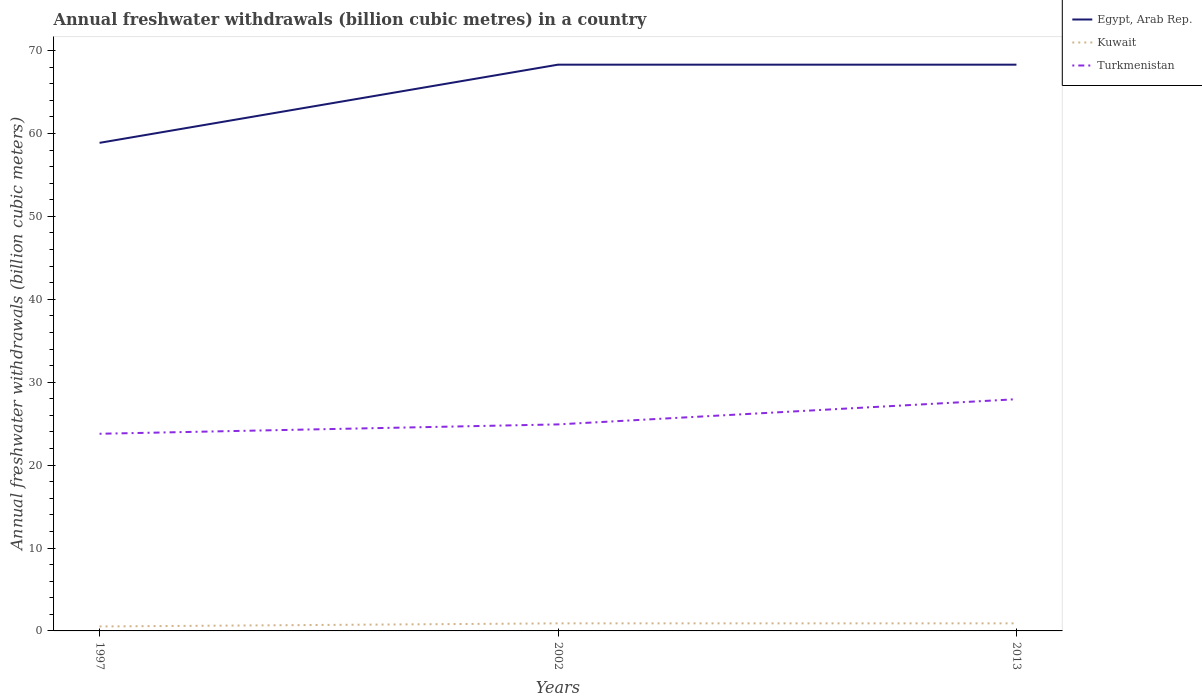Does the line corresponding to Egypt, Arab Rep. intersect with the line corresponding to Turkmenistan?
Your answer should be compact. No. Across all years, what is the maximum annual freshwater withdrawals in Kuwait?
Keep it short and to the point. 0.54. In which year was the annual freshwater withdrawals in Egypt, Arab Rep. maximum?
Provide a succinct answer. 1997. What is the total annual freshwater withdrawals in Turkmenistan in the graph?
Make the answer very short. -3.04. What is the difference between the highest and the second highest annual freshwater withdrawals in Egypt, Arab Rep.?
Your answer should be very brief. 9.43. What is the difference between the highest and the lowest annual freshwater withdrawals in Kuwait?
Offer a terse response. 2. Is the annual freshwater withdrawals in Turkmenistan strictly greater than the annual freshwater withdrawals in Kuwait over the years?
Provide a succinct answer. No. How many lines are there?
Your response must be concise. 3. How many years are there in the graph?
Your response must be concise. 3. What is the difference between two consecutive major ticks on the Y-axis?
Offer a very short reply. 10. Are the values on the major ticks of Y-axis written in scientific E-notation?
Make the answer very short. No. Where does the legend appear in the graph?
Your answer should be compact. Top right. How many legend labels are there?
Offer a very short reply. 3. What is the title of the graph?
Your answer should be compact. Annual freshwater withdrawals (billion cubic metres) in a country. What is the label or title of the Y-axis?
Keep it short and to the point. Annual freshwater withdrawals (billion cubic meters). What is the Annual freshwater withdrawals (billion cubic meters) of Egypt, Arab Rep. in 1997?
Your answer should be compact. 58.87. What is the Annual freshwater withdrawals (billion cubic meters) in Kuwait in 1997?
Provide a short and direct response. 0.54. What is the Annual freshwater withdrawals (billion cubic meters) in Turkmenistan in 1997?
Make the answer very short. 23.78. What is the Annual freshwater withdrawals (billion cubic meters) of Egypt, Arab Rep. in 2002?
Provide a succinct answer. 68.3. What is the Annual freshwater withdrawals (billion cubic meters) in Kuwait in 2002?
Provide a succinct answer. 0.91. What is the Annual freshwater withdrawals (billion cubic meters) of Turkmenistan in 2002?
Your response must be concise. 24.91. What is the Annual freshwater withdrawals (billion cubic meters) of Egypt, Arab Rep. in 2013?
Your response must be concise. 68.3. What is the Annual freshwater withdrawals (billion cubic meters) in Kuwait in 2013?
Provide a short and direct response. 0.91. What is the Annual freshwater withdrawals (billion cubic meters) of Turkmenistan in 2013?
Keep it short and to the point. 27.95. Across all years, what is the maximum Annual freshwater withdrawals (billion cubic meters) of Egypt, Arab Rep.?
Offer a terse response. 68.3. Across all years, what is the maximum Annual freshwater withdrawals (billion cubic meters) in Kuwait?
Your answer should be very brief. 0.91. Across all years, what is the maximum Annual freshwater withdrawals (billion cubic meters) in Turkmenistan?
Your response must be concise. 27.95. Across all years, what is the minimum Annual freshwater withdrawals (billion cubic meters) in Egypt, Arab Rep.?
Ensure brevity in your answer.  58.87. Across all years, what is the minimum Annual freshwater withdrawals (billion cubic meters) of Kuwait?
Keep it short and to the point. 0.54. Across all years, what is the minimum Annual freshwater withdrawals (billion cubic meters) of Turkmenistan?
Provide a succinct answer. 23.78. What is the total Annual freshwater withdrawals (billion cubic meters) in Egypt, Arab Rep. in the graph?
Provide a short and direct response. 195.47. What is the total Annual freshwater withdrawals (billion cubic meters) of Kuwait in the graph?
Your answer should be compact. 2.36. What is the total Annual freshwater withdrawals (billion cubic meters) of Turkmenistan in the graph?
Make the answer very short. 76.64. What is the difference between the Annual freshwater withdrawals (billion cubic meters) in Egypt, Arab Rep. in 1997 and that in 2002?
Offer a terse response. -9.43. What is the difference between the Annual freshwater withdrawals (billion cubic meters) in Kuwait in 1997 and that in 2002?
Make the answer very short. -0.38. What is the difference between the Annual freshwater withdrawals (billion cubic meters) in Turkmenistan in 1997 and that in 2002?
Your response must be concise. -1.13. What is the difference between the Annual freshwater withdrawals (billion cubic meters) in Egypt, Arab Rep. in 1997 and that in 2013?
Provide a succinct answer. -9.43. What is the difference between the Annual freshwater withdrawals (billion cubic meters) of Kuwait in 1997 and that in 2013?
Offer a very short reply. -0.38. What is the difference between the Annual freshwater withdrawals (billion cubic meters) of Turkmenistan in 1997 and that in 2013?
Ensure brevity in your answer.  -4.17. What is the difference between the Annual freshwater withdrawals (billion cubic meters) of Turkmenistan in 2002 and that in 2013?
Make the answer very short. -3.04. What is the difference between the Annual freshwater withdrawals (billion cubic meters) in Egypt, Arab Rep. in 1997 and the Annual freshwater withdrawals (billion cubic meters) in Kuwait in 2002?
Offer a very short reply. 57.96. What is the difference between the Annual freshwater withdrawals (billion cubic meters) of Egypt, Arab Rep. in 1997 and the Annual freshwater withdrawals (billion cubic meters) of Turkmenistan in 2002?
Keep it short and to the point. 33.96. What is the difference between the Annual freshwater withdrawals (billion cubic meters) in Kuwait in 1997 and the Annual freshwater withdrawals (billion cubic meters) in Turkmenistan in 2002?
Your answer should be very brief. -24.37. What is the difference between the Annual freshwater withdrawals (billion cubic meters) of Egypt, Arab Rep. in 1997 and the Annual freshwater withdrawals (billion cubic meters) of Kuwait in 2013?
Provide a short and direct response. 57.96. What is the difference between the Annual freshwater withdrawals (billion cubic meters) in Egypt, Arab Rep. in 1997 and the Annual freshwater withdrawals (billion cubic meters) in Turkmenistan in 2013?
Offer a terse response. 30.92. What is the difference between the Annual freshwater withdrawals (billion cubic meters) in Kuwait in 1997 and the Annual freshwater withdrawals (billion cubic meters) in Turkmenistan in 2013?
Offer a terse response. -27.41. What is the difference between the Annual freshwater withdrawals (billion cubic meters) in Egypt, Arab Rep. in 2002 and the Annual freshwater withdrawals (billion cubic meters) in Kuwait in 2013?
Keep it short and to the point. 67.39. What is the difference between the Annual freshwater withdrawals (billion cubic meters) in Egypt, Arab Rep. in 2002 and the Annual freshwater withdrawals (billion cubic meters) in Turkmenistan in 2013?
Give a very brief answer. 40.35. What is the difference between the Annual freshwater withdrawals (billion cubic meters) of Kuwait in 2002 and the Annual freshwater withdrawals (billion cubic meters) of Turkmenistan in 2013?
Keep it short and to the point. -27.04. What is the average Annual freshwater withdrawals (billion cubic meters) of Egypt, Arab Rep. per year?
Provide a short and direct response. 65.16. What is the average Annual freshwater withdrawals (billion cubic meters) of Kuwait per year?
Offer a very short reply. 0.79. What is the average Annual freshwater withdrawals (billion cubic meters) of Turkmenistan per year?
Your answer should be compact. 25.55. In the year 1997, what is the difference between the Annual freshwater withdrawals (billion cubic meters) of Egypt, Arab Rep. and Annual freshwater withdrawals (billion cubic meters) of Kuwait?
Ensure brevity in your answer.  58.33. In the year 1997, what is the difference between the Annual freshwater withdrawals (billion cubic meters) of Egypt, Arab Rep. and Annual freshwater withdrawals (billion cubic meters) of Turkmenistan?
Keep it short and to the point. 35.09. In the year 1997, what is the difference between the Annual freshwater withdrawals (billion cubic meters) in Kuwait and Annual freshwater withdrawals (billion cubic meters) in Turkmenistan?
Give a very brief answer. -23.24. In the year 2002, what is the difference between the Annual freshwater withdrawals (billion cubic meters) in Egypt, Arab Rep. and Annual freshwater withdrawals (billion cubic meters) in Kuwait?
Your answer should be compact. 67.39. In the year 2002, what is the difference between the Annual freshwater withdrawals (billion cubic meters) in Egypt, Arab Rep. and Annual freshwater withdrawals (billion cubic meters) in Turkmenistan?
Provide a succinct answer. 43.39. In the year 2002, what is the difference between the Annual freshwater withdrawals (billion cubic meters) of Kuwait and Annual freshwater withdrawals (billion cubic meters) of Turkmenistan?
Give a very brief answer. -24. In the year 2013, what is the difference between the Annual freshwater withdrawals (billion cubic meters) in Egypt, Arab Rep. and Annual freshwater withdrawals (billion cubic meters) in Kuwait?
Your answer should be very brief. 67.39. In the year 2013, what is the difference between the Annual freshwater withdrawals (billion cubic meters) of Egypt, Arab Rep. and Annual freshwater withdrawals (billion cubic meters) of Turkmenistan?
Make the answer very short. 40.35. In the year 2013, what is the difference between the Annual freshwater withdrawals (billion cubic meters) of Kuwait and Annual freshwater withdrawals (billion cubic meters) of Turkmenistan?
Keep it short and to the point. -27.04. What is the ratio of the Annual freshwater withdrawals (billion cubic meters) in Egypt, Arab Rep. in 1997 to that in 2002?
Give a very brief answer. 0.86. What is the ratio of the Annual freshwater withdrawals (billion cubic meters) in Kuwait in 1997 to that in 2002?
Your response must be concise. 0.59. What is the ratio of the Annual freshwater withdrawals (billion cubic meters) of Turkmenistan in 1997 to that in 2002?
Offer a very short reply. 0.95. What is the ratio of the Annual freshwater withdrawals (billion cubic meters) of Egypt, Arab Rep. in 1997 to that in 2013?
Provide a succinct answer. 0.86. What is the ratio of the Annual freshwater withdrawals (billion cubic meters) of Kuwait in 1997 to that in 2013?
Provide a short and direct response. 0.59. What is the ratio of the Annual freshwater withdrawals (billion cubic meters) in Turkmenistan in 1997 to that in 2013?
Offer a terse response. 0.85. What is the ratio of the Annual freshwater withdrawals (billion cubic meters) of Egypt, Arab Rep. in 2002 to that in 2013?
Your answer should be very brief. 1. What is the ratio of the Annual freshwater withdrawals (billion cubic meters) of Kuwait in 2002 to that in 2013?
Make the answer very short. 1. What is the ratio of the Annual freshwater withdrawals (billion cubic meters) of Turkmenistan in 2002 to that in 2013?
Your response must be concise. 0.89. What is the difference between the highest and the second highest Annual freshwater withdrawals (billion cubic meters) in Egypt, Arab Rep.?
Provide a short and direct response. 0. What is the difference between the highest and the second highest Annual freshwater withdrawals (billion cubic meters) in Kuwait?
Make the answer very short. 0. What is the difference between the highest and the second highest Annual freshwater withdrawals (billion cubic meters) of Turkmenistan?
Your answer should be compact. 3.04. What is the difference between the highest and the lowest Annual freshwater withdrawals (billion cubic meters) of Egypt, Arab Rep.?
Offer a terse response. 9.43. What is the difference between the highest and the lowest Annual freshwater withdrawals (billion cubic meters) of Kuwait?
Offer a terse response. 0.38. What is the difference between the highest and the lowest Annual freshwater withdrawals (billion cubic meters) of Turkmenistan?
Your answer should be compact. 4.17. 